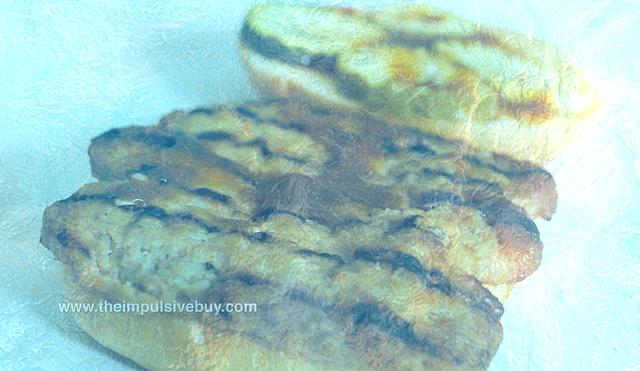What object is recognizable as the subject of the image?
A. A cup of coffee on the side.
B. A slice of pizza at the bottom.
C. A loaf of bread in the middle.
Answer with the option's letter from the given choices directly.
 C. 